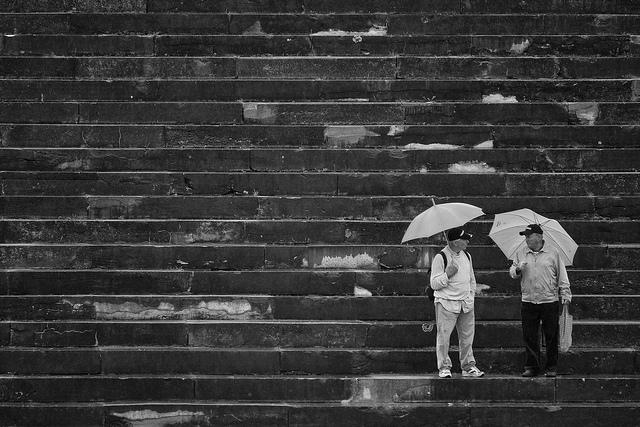Where are the men?
Give a very brief answer. On steps. Why are the men with umbrellas?
Keep it brief. Raining. Are both men wearing hats?
Write a very short answer. Yes. 